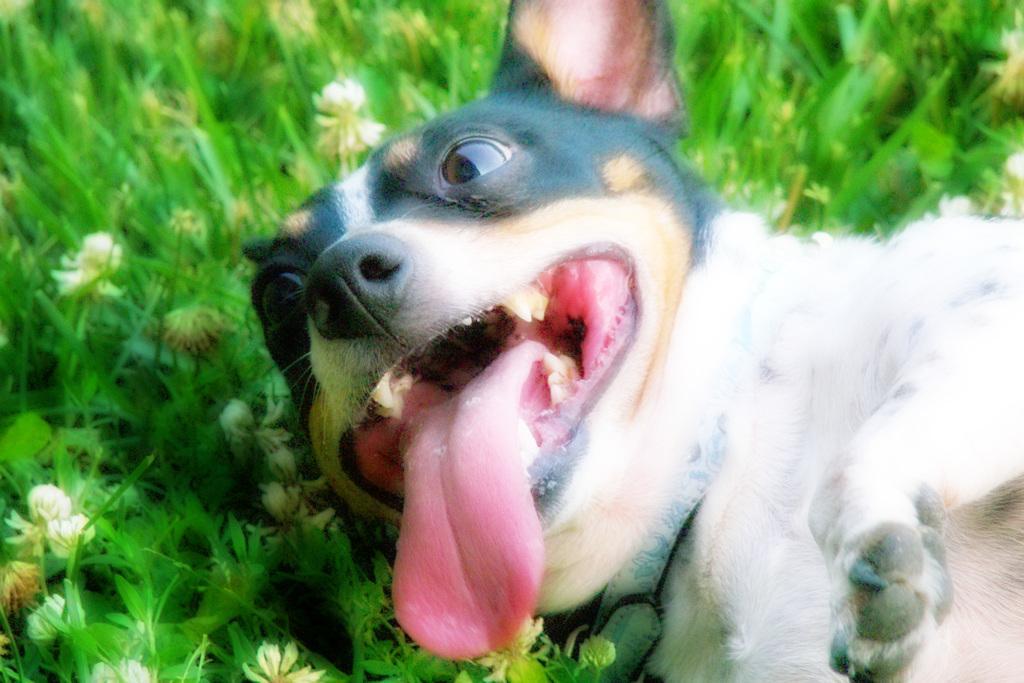Describe this image in one or two sentences. In this image I can see a dog which is in black and white color and it is laying on the ground. On the left side I can see the green color grass and some white color flowers. 